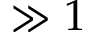Convert formula to latex. <formula><loc_0><loc_0><loc_500><loc_500>\gg 1</formula> 